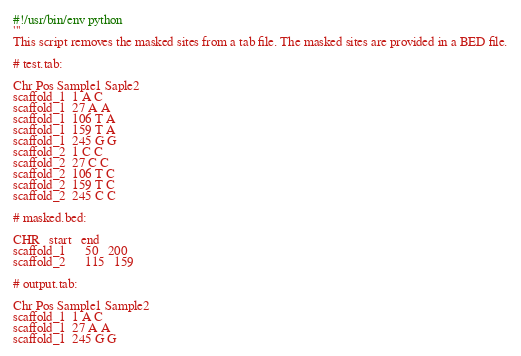<code> <loc_0><loc_0><loc_500><loc_500><_Python_>#!/usr/bin/env python
'''
This script removes the masked sites from a tab file. The masked sites are provided in a BED file.

# test.tab:

Chr Pos Sample1 Saple2
scaffold_1  1 A C
scaffold_1  27 A A
scaffold_1  106 T A
scaffold_1  159 T A
scaffold_1  245 G G
scaffold_2  1 C C
scaffold_2  27 C C
scaffold_2  106 T C
scaffold_2  159 T C
scaffold_2  245 C C

# masked.bed:

CHR   start   end
scaffold_1      50   200
scaffold_2      115   159

# output.tab:

Chr Pos Sample1 Sample2
scaffold_1  1 A C
scaffold_1  27 A A
scaffold_1  245 G G</code> 